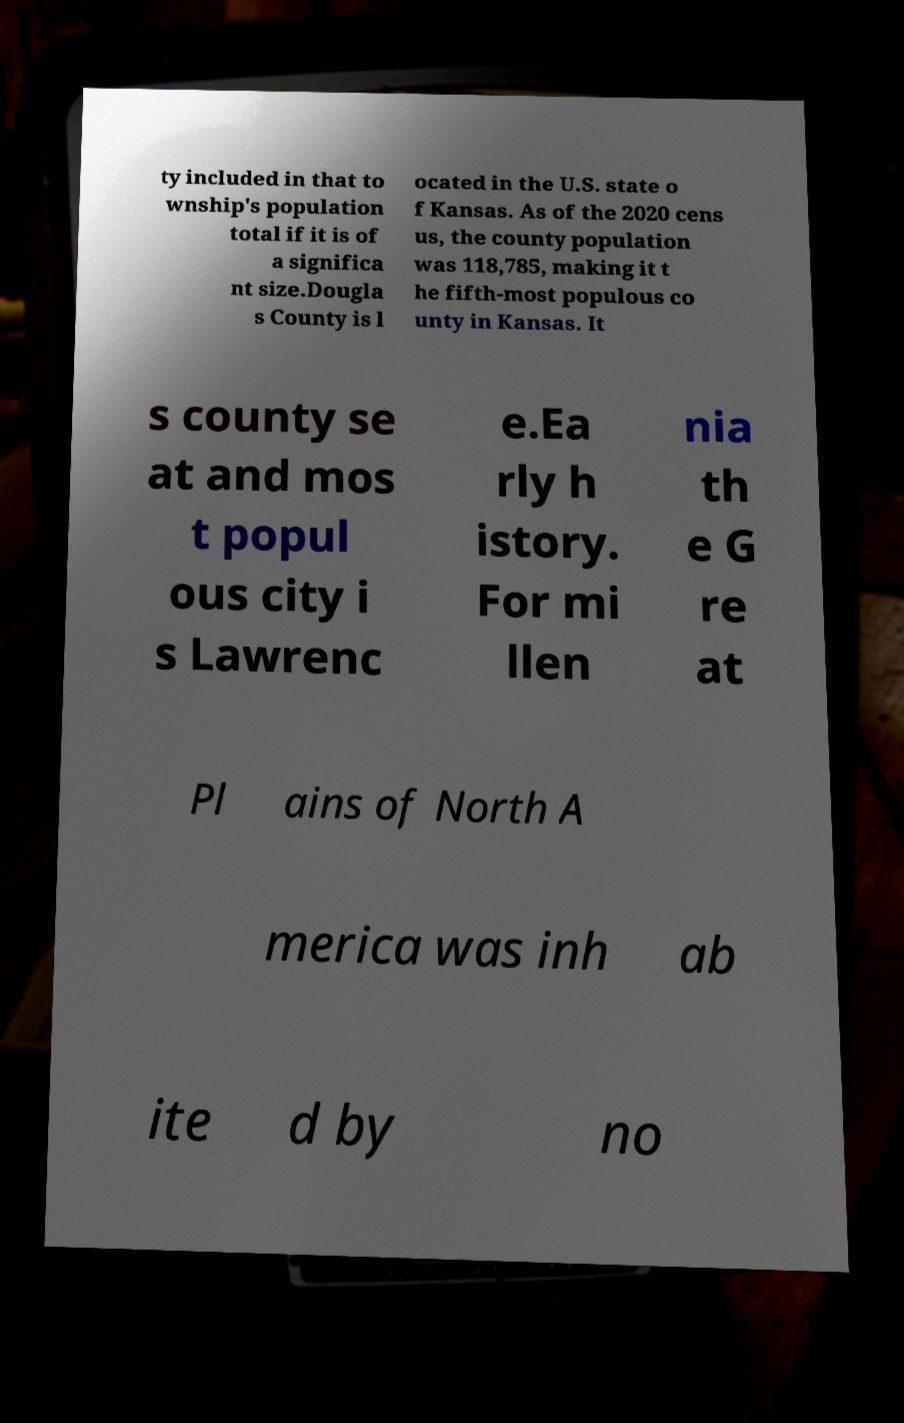Can you accurately transcribe the text from the provided image for me? ty included in that to wnship's population total if it is of a significa nt size.Dougla s County is l ocated in the U.S. state o f Kansas. As of the 2020 cens us, the county population was 118,785, making it t he fifth-most populous co unty in Kansas. It s county se at and mos t popul ous city i s Lawrenc e.Ea rly h istory. For mi llen nia th e G re at Pl ains of North A merica was inh ab ite d by no 